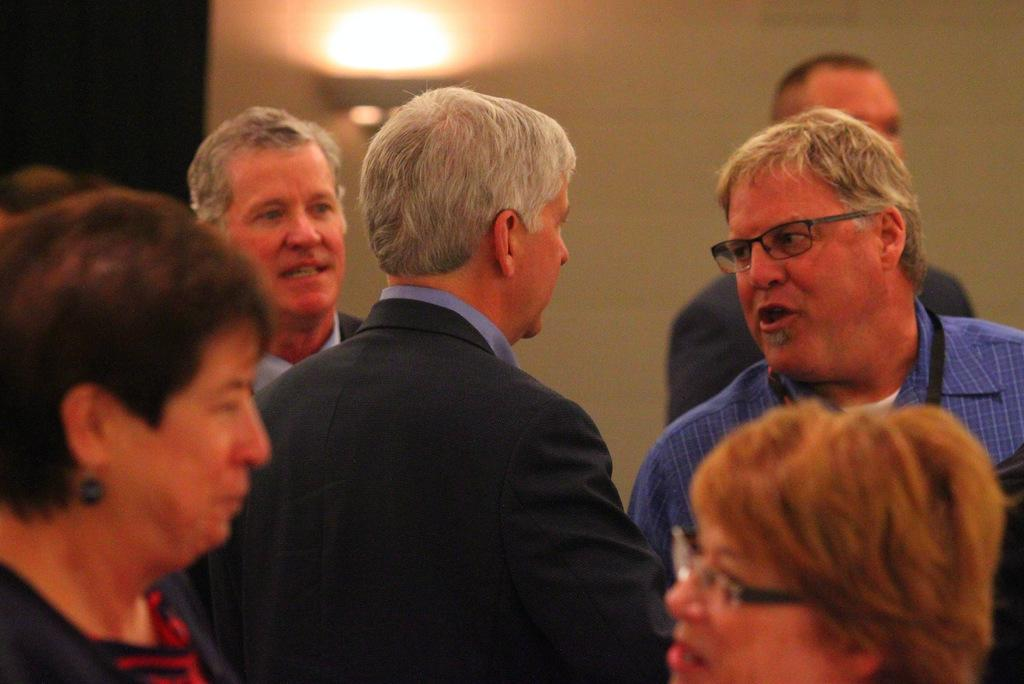How many people are in the image? There is a group of people standing in the image. Can you describe the setting of the image? The image features a group of people standing together. What is visible on the wall in the background of the image? There is a light on the wall in the background of the image. What type of vessel is being used by the person with the injured knee in the image? There is no vessel or person with an injured knee present in the image. 